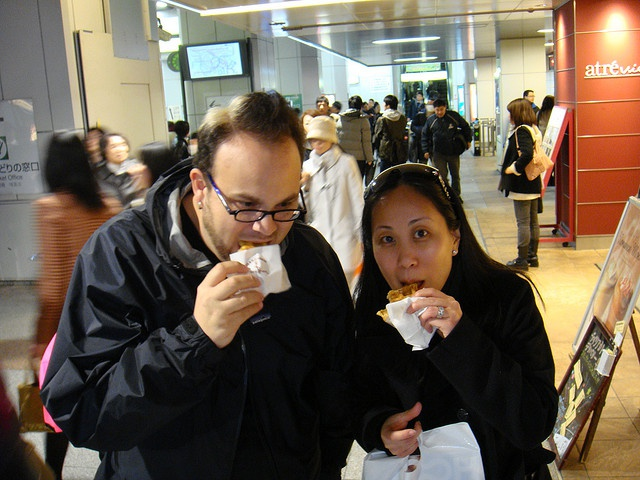Describe the objects in this image and their specific colors. I can see people in gray, black, and tan tones, people in gray, black, brown, and maroon tones, people in gray, black, maroon, and brown tones, people in gray, lightgray, darkgray, and tan tones, and people in gray, black, olive, maroon, and tan tones in this image. 